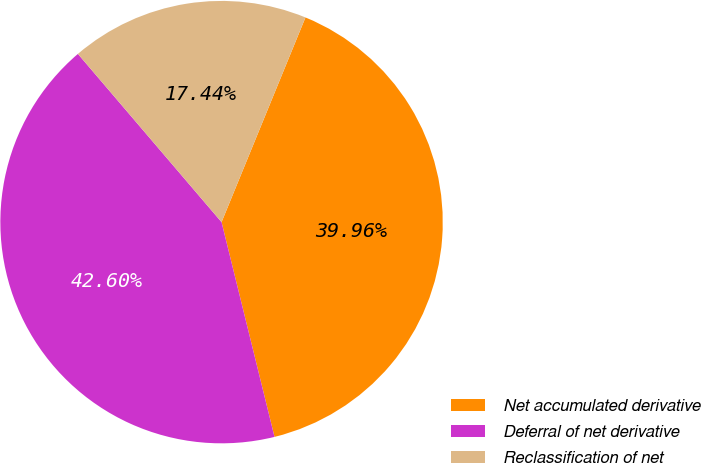<chart> <loc_0><loc_0><loc_500><loc_500><pie_chart><fcel>Net accumulated derivative<fcel>Deferral of net derivative<fcel>Reclassification of net<nl><fcel>39.96%<fcel>42.6%<fcel>17.44%<nl></chart> 